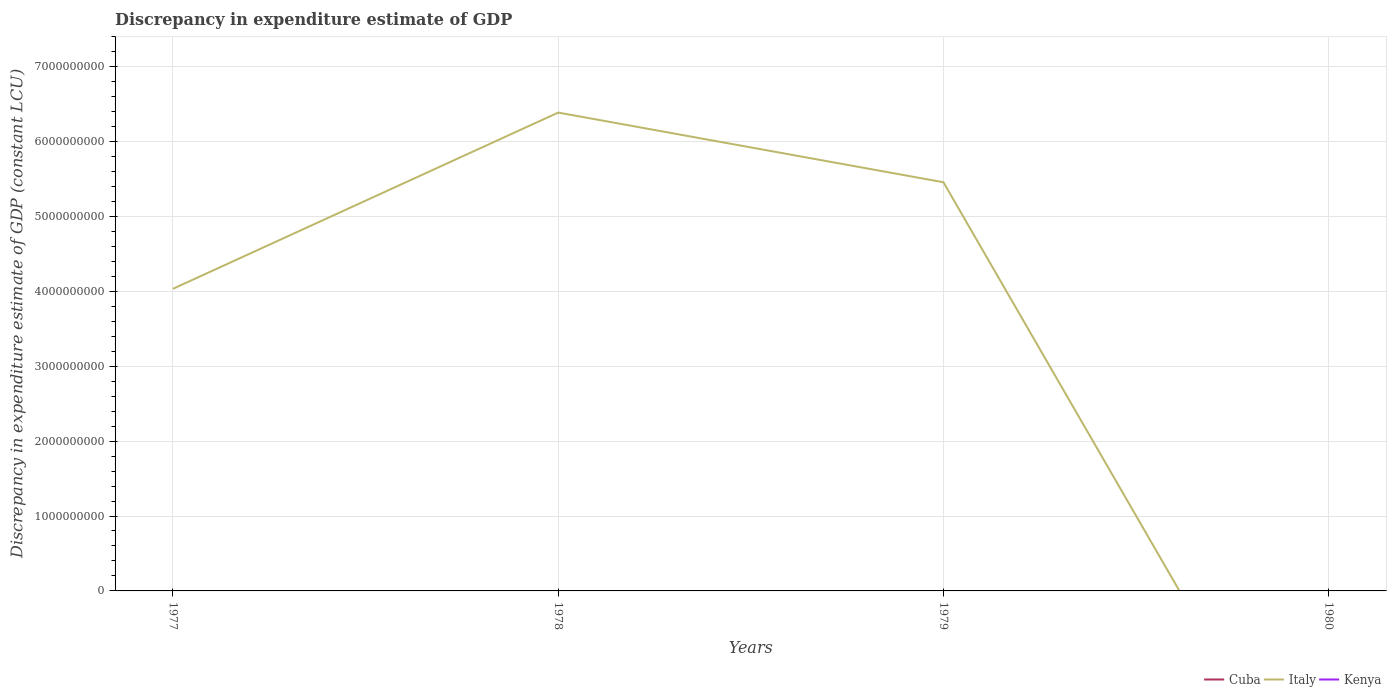How many different coloured lines are there?
Provide a short and direct response. 1. Does the line corresponding to Cuba intersect with the line corresponding to Kenya?
Make the answer very short. No. What is the total discrepancy in expenditure estimate of GDP in Italy in the graph?
Offer a very short reply. -2.35e+09. Is the discrepancy in expenditure estimate of GDP in Kenya strictly greater than the discrepancy in expenditure estimate of GDP in Italy over the years?
Keep it short and to the point. Yes. How many years are there in the graph?
Your response must be concise. 4. Are the values on the major ticks of Y-axis written in scientific E-notation?
Offer a terse response. No. How are the legend labels stacked?
Keep it short and to the point. Horizontal. What is the title of the graph?
Offer a very short reply. Discrepancy in expenditure estimate of GDP. Does "Croatia" appear as one of the legend labels in the graph?
Ensure brevity in your answer.  No. What is the label or title of the X-axis?
Offer a terse response. Years. What is the label or title of the Y-axis?
Make the answer very short. Discrepancy in expenditure estimate of GDP (constant LCU). What is the Discrepancy in expenditure estimate of GDP (constant LCU) of Cuba in 1977?
Keep it short and to the point. 0. What is the Discrepancy in expenditure estimate of GDP (constant LCU) in Italy in 1977?
Make the answer very short. 4.03e+09. What is the Discrepancy in expenditure estimate of GDP (constant LCU) of Cuba in 1978?
Provide a short and direct response. 0. What is the Discrepancy in expenditure estimate of GDP (constant LCU) of Italy in 1978?
Keep it short and to the point. 6.39e+09. What is the Discrepancy in expenditure estimate of GDP (constant LCU) of Cuba in 1979?
Provide a short and direct response. 0. What is the Discrepancy in expenditure estimate of GDP (constant LCU) of Italy in 1979?
Provide a succinct answer. 5.46e+09. What is the Discrepancy in expenditure estimate of GDP (constant LCU) of Cuba in 1980?
Keep it short and to the point. 0. What is the Discrepancy in expenditure estimate of GDP (constant LCU) in Italy in 1980?
Offer a very short reply. 0. Across all years, what is the maximum Discrepancy in expenditure estimate of GDP (constant LCU) in Italy?
Your response must be concise. 6.39e+09. Across all years, what is the minimum Discrepancy in expenditure estimate of GDP (constant LCU) of Italy?
Your answer should be very brief. 0. What is the total Discrepancy in expenditure estimate of GDP (constant LCU) of Italy in the graph?
Provide a short and direct response. 1.59e+1. What is the total Discrepancy in expenditure estimate of GDP (constant LCU) of Kenya in the graph?
Offer a very short reply. 0. What is the difference between the Discrepancy in expenditure estimate of GDP (constant LCU) of Italy in 1977 and that in 1978?
Your answer should be very brief. -2.35e+09. What is the difference between the Discrepancy in expenditure estimate of GDP (constant LCU) in Italy in 1977 and that in 1979?
Offer a terse response. -1.42e+09. What is the difference between the Discrepancy in expenditure estimate of GDP (constant LCU) of Italy in 1978 and that in 1979?
Ensure brevity in your answer.  9.30e+08. What is the average Discrepancy in expenditure estimate of GDP (constant LCU) of Cuba per year?
Ensure brevity in your answer.  0. What is the average Discrepancy in expenditure estimate of GDP (constant LCU) of Italy per year?
Your response must be concise. 3.97e+09. What is the average Discrepancy in expenditure estimate of GDP (constant LCU) of Kenya per year?
Keep it short and to the point. 0. What is the ratio of the Discrepancy in expenditure estimate of GDP (constant LCU) of Italy in 1977 to that in 1978?
Provide a short and direct response. 0.63. What is the ratio of the Discrepancy in expenditure estimate of GDP (constant LCU) in Italy in 1977 to that in 1979?
Offer a terse response. 0.74. What is the ratio of the Discrepancy in expenditure estimate of GDP (constant LCU) in Italy in 1978 to that in 1979?
Your answer should be very brief. 1.17. What is the difference between the highest and the second highest Discrepancy in expenditure estimate of GDP (constant LCU) of Italy?
Ensure brevity in your answer.  9.30e+08. What is the difference between the highest and the lowest Discrepancy in expenditure estimate of GDP (constant LCU) of Italy?
Provide a succinct answer. 6.39e+09. 